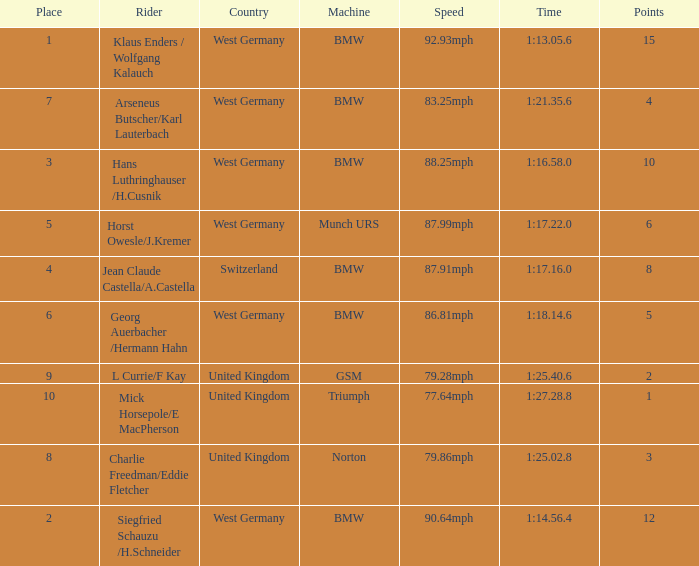Which places have points larger than 10? None. 